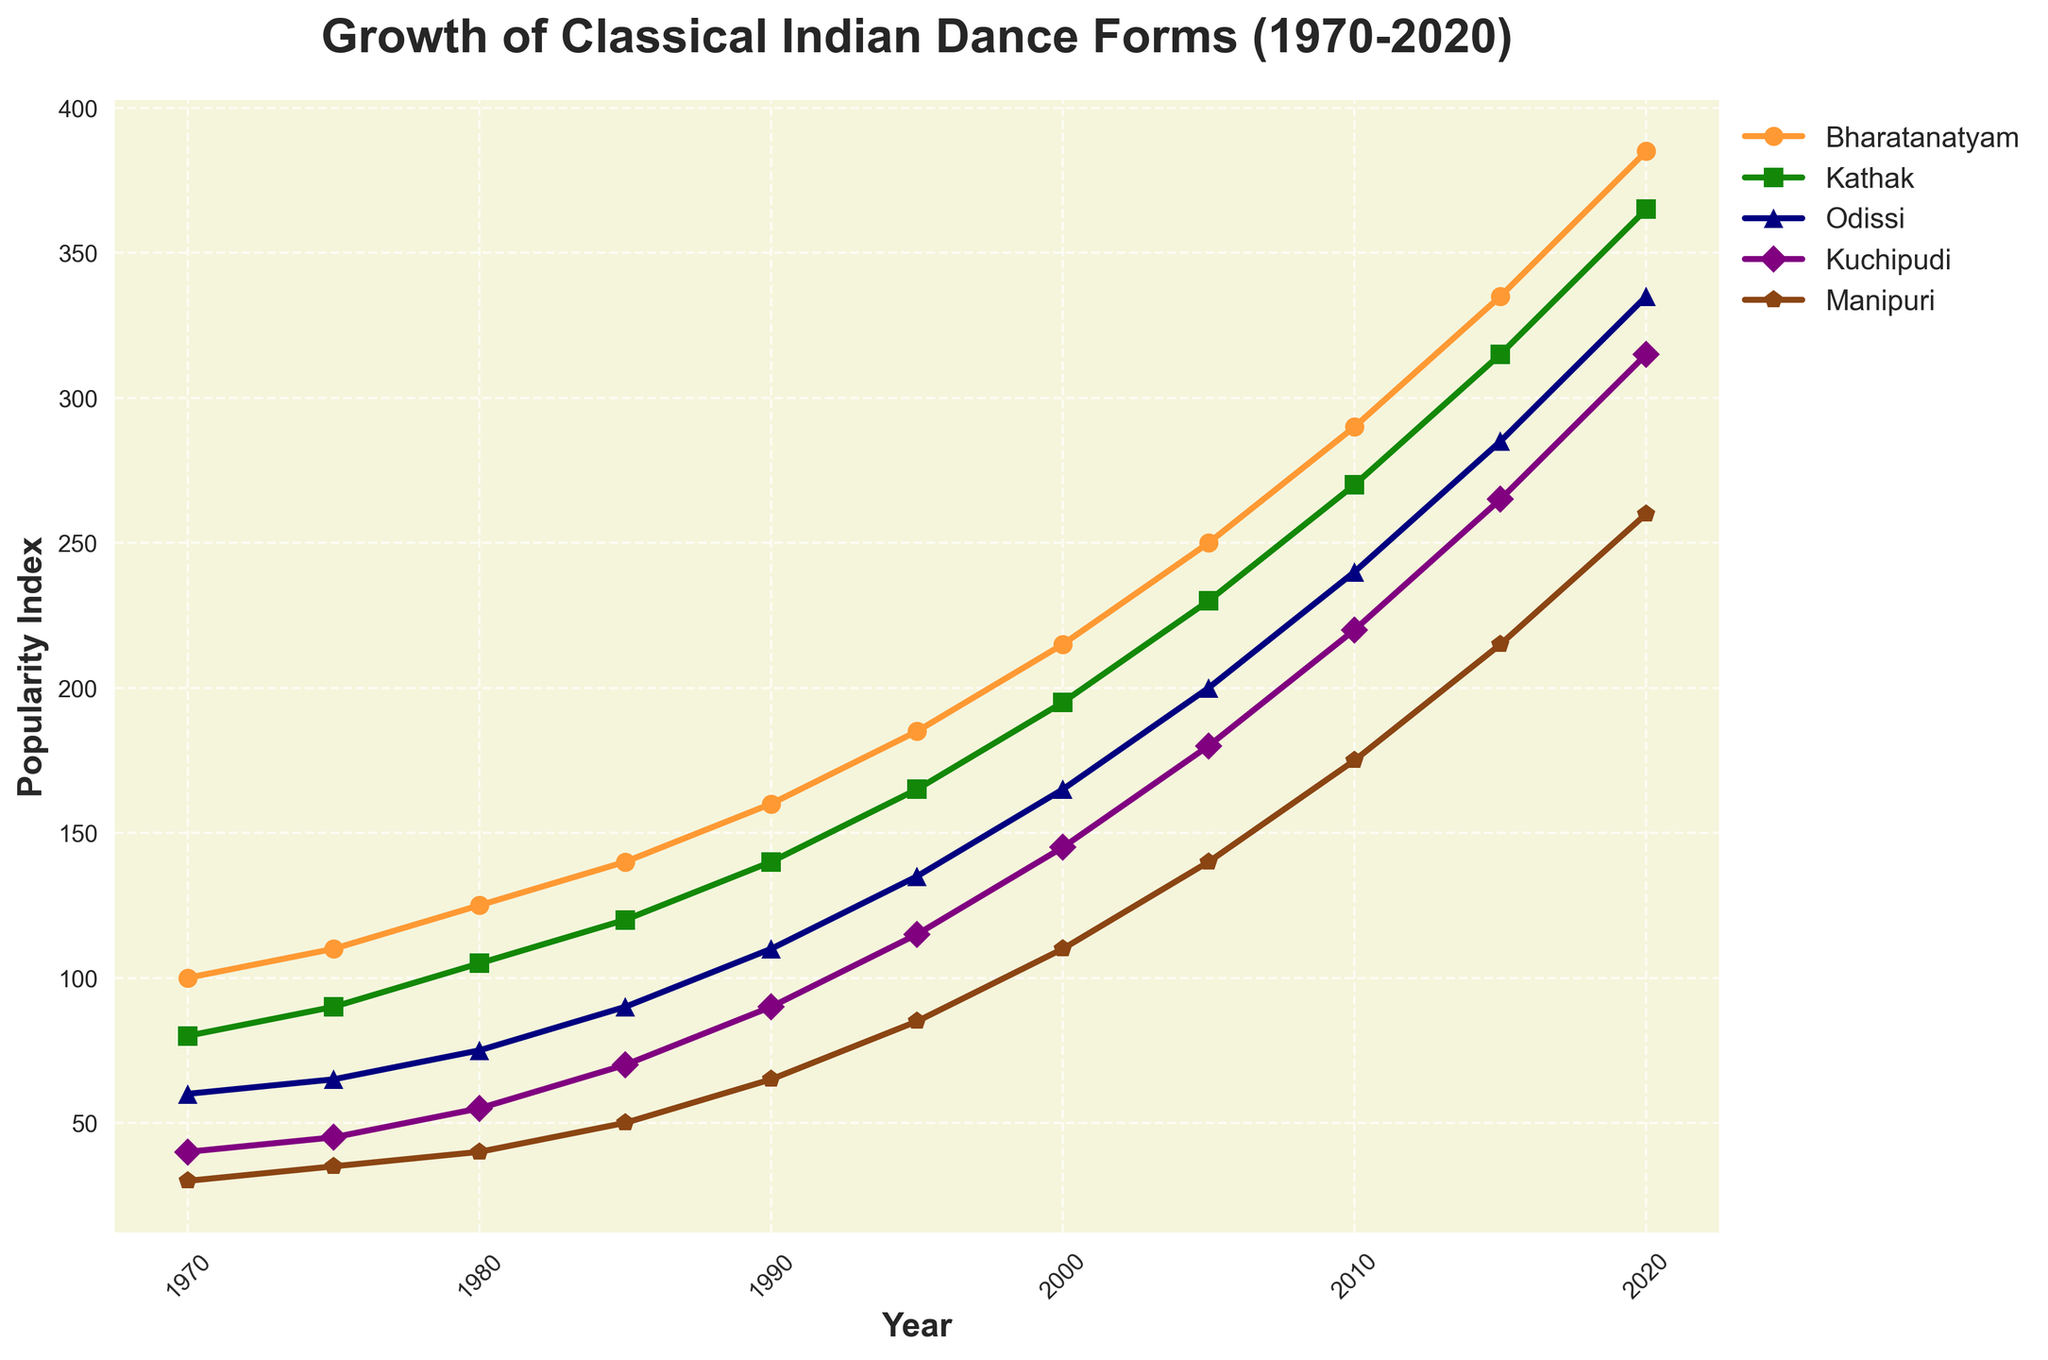What is the popularity index of Bharatanatyam in the year 2000? Locate the point on the Bharatanatyam line corresponding to the year 2000 on the x-axis, then read the y-axis value.
Answer: 215 Which dance form had the lowest popularity in 1985? Identify the point on the year 1985 on the x-axis and compare the y-values of all dance forms. The lowest y-value represents the least popular dance form.
Answer: Manipuri What is the average popularity increase per decade for Odissi from 1990 to 2020? Calculate the difference in popularity index between 1990 and 2020 for Odissi (335 - 110 = 225). Divide this difference by the number of decades (30 years / 10 years per decade = 3). Average increase per decade is 225 / 3.
Answer: 75 Which dance forms have crossed a popularity index of 300 by the year 2015? Find the year 2015 on the x-axis. Check which dance forms have their y-values above 300.
Answer: Bharatanatyam, Kathak By how much did Kuchipudi's popularity increase from 1975 to 2005? Locate the points for Kuchipudi on the years 1975 and 2005. Subtract the y-value of 1975 from the y-value of 2005 (180 - 45).
Answer: 135 How much more popular was Kathak compared to Manipuri in 2010? Find the y-values for Kathak and Manipuri in the year 2010. Subtract the y-value of Manipuri from that of Kathak (270 - 175).
Answer: 95 Which dance form showed the greatest increase in popularity between 1980 and 1990? Calculate the increase in popularity for each dance form between 1980 and 1990. For Bharatanatyam: 160 - 125 = 35, Kathak: 140 - 105 = 35, Odissi: 110 - 75 = 35, Kuchipudi: 90 - 55 = 35, Manipuri: 65 - 40 = 25. Compare these values.
Answer: Odissi What is the combined popularity index of all dance forms in 2000? Sum the y-values of all dance forms for the year 2000 (215 + 195 + 165 + 145 + 110).
Answer: 830 